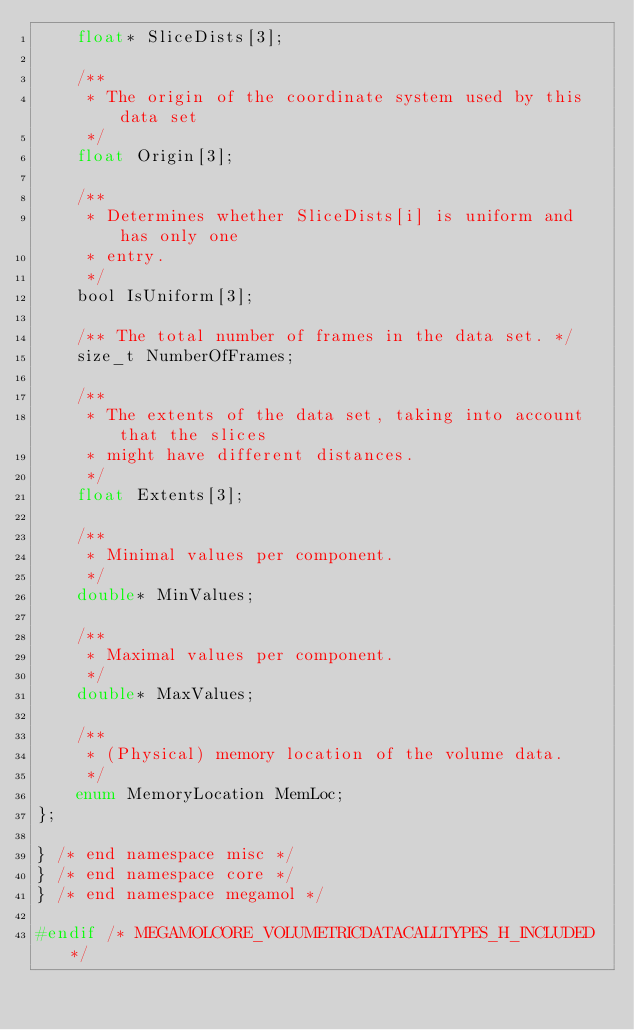Convert code to text. <code><loc_0><loc_0><loc_500><loc_500><_C_>    float* SliceDists[3];

    /**
     * The origin of the coordinate system used by this data set
     */
    float Origin[3];

    /**
     * Determines whether SliceDists[i] is uniform and has only one
     * entry.
     */
    bool IsUniform[3];

    /** The total number of frames in the data set. */
    size_t NumberOfFrames;

    /**
     * The extents of the data set, taking into account that the slices
     * might have different distances.
     */
    float Extents[3];

    /**
     * Minimal values per component.
     */
    double* MinValues;

    /**
     * Maximal values per component.
     */
    double* MaxValues;

	/**
	 * (Physical) memory location of the volume data.
	 */
	enum MemoryLocation	MemLoc;
};

} /* end namespace misc */
} /* end namespace core */
} /* end namespace megamol */

#endif /* MEGAMOLCORE_VOLUMETRICDATACALLTYPES_H_INCLUDED */
</code> 